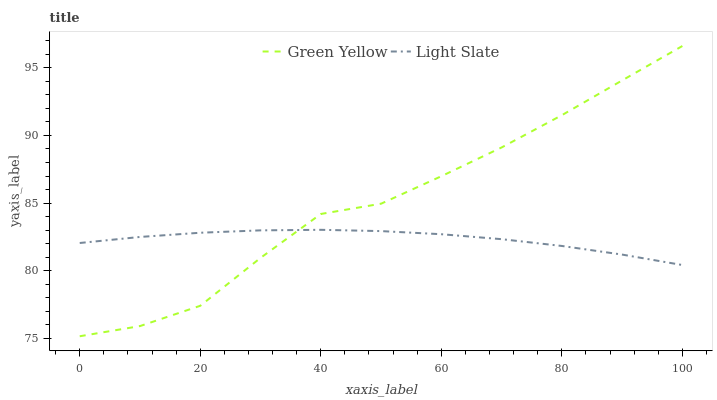Does Light Slate have the minimum area under the curve?
Answer yes or no. Yes. Does Green Yellow have the maximum area under the curve?
Answer yes or no. Yes. Does Green Yellow have the minimum area under the curve?
Answer yes or no. No. Is Light Slate the smoothest?
Answer yes or no. Yes. Is Green Yellow the roughest?
Answer yes or no. Yes. Is Green Yellow the smoothest?
Answer yes or no. No. Does Green Yellow have the lowest value?
Answer yes or no. Yes. Does Green Yellow have the highest value?
Answer yes or no. Yes. Does Light Slate intersect Green Yellow?
Answer yes or no. Yes. Is Light Slate less than Green Yellow?
Answer yes or no. No. Is Light Slate greater than Green Yellow?
Answer yes or no. No. 